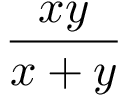Convert formula to latex. <formula><loc_0><loc_0><loc_500><loc_500>\frac { x y } { x + y }</formula> 